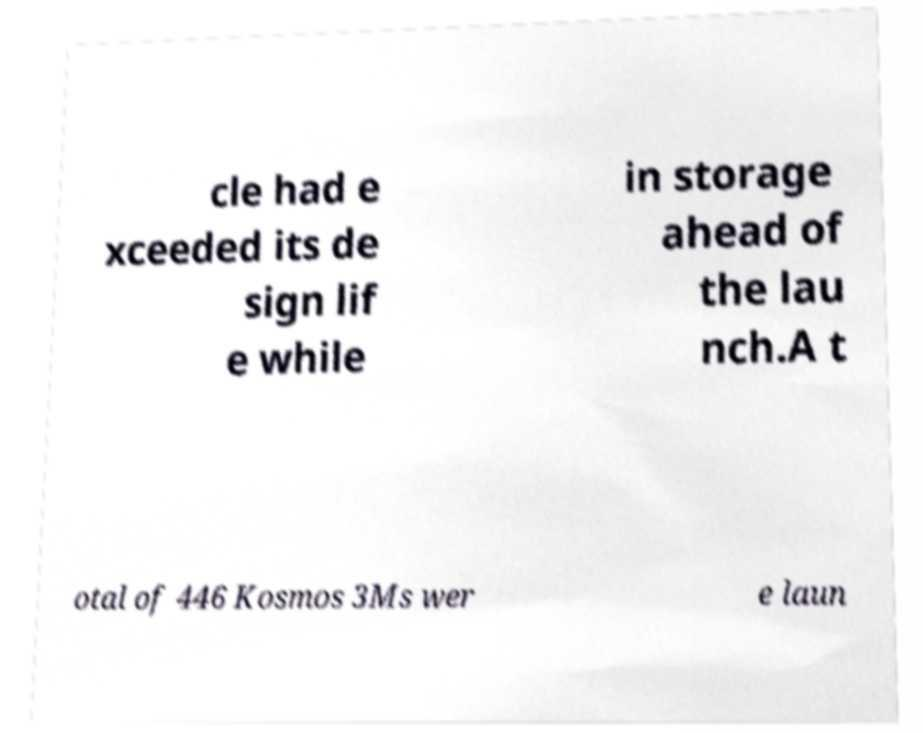For documentation purposes, I need the text within this image transcribed. Could you provide that? cle had e xceeded its de sign lif e while in storage ahead of the lau nch.A t otal of 446 Kosmos 3Ms wer e laun 